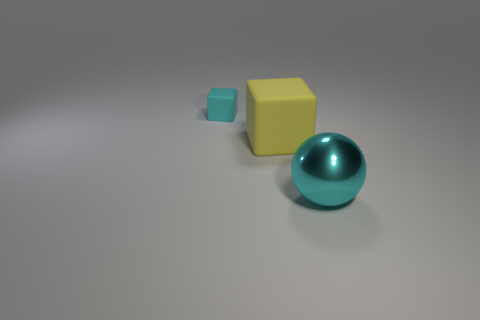Can you comment on the sizes and placement of the objects? The ball in the image is medium-sized and is placed at the forefront, drawing attention due to its position and reflective surface. Behind it, staggering towards the back, are the two cubes; the larger yellow one is closer and the smaller teal one is further away, creating a sense of depth and perspective in the composition. 